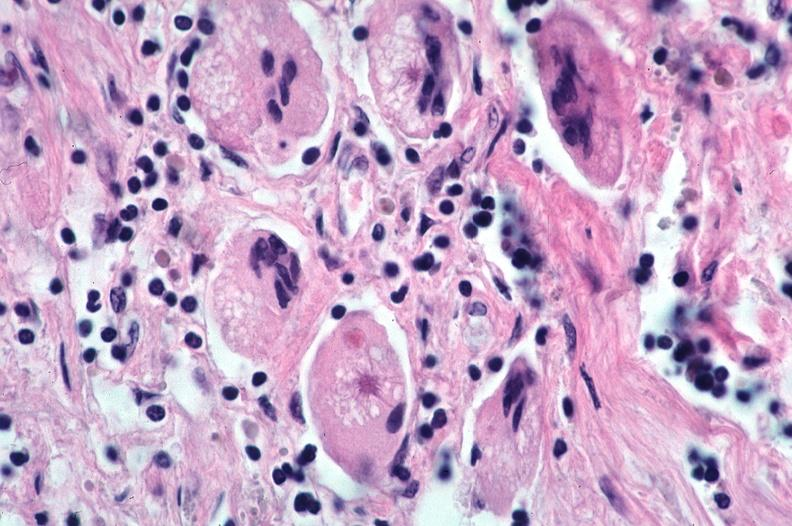how does this image show lung, sarcoidosis, multinucleated giant cells?
Answer the question using a single word or phrase. With asteroid bodies 